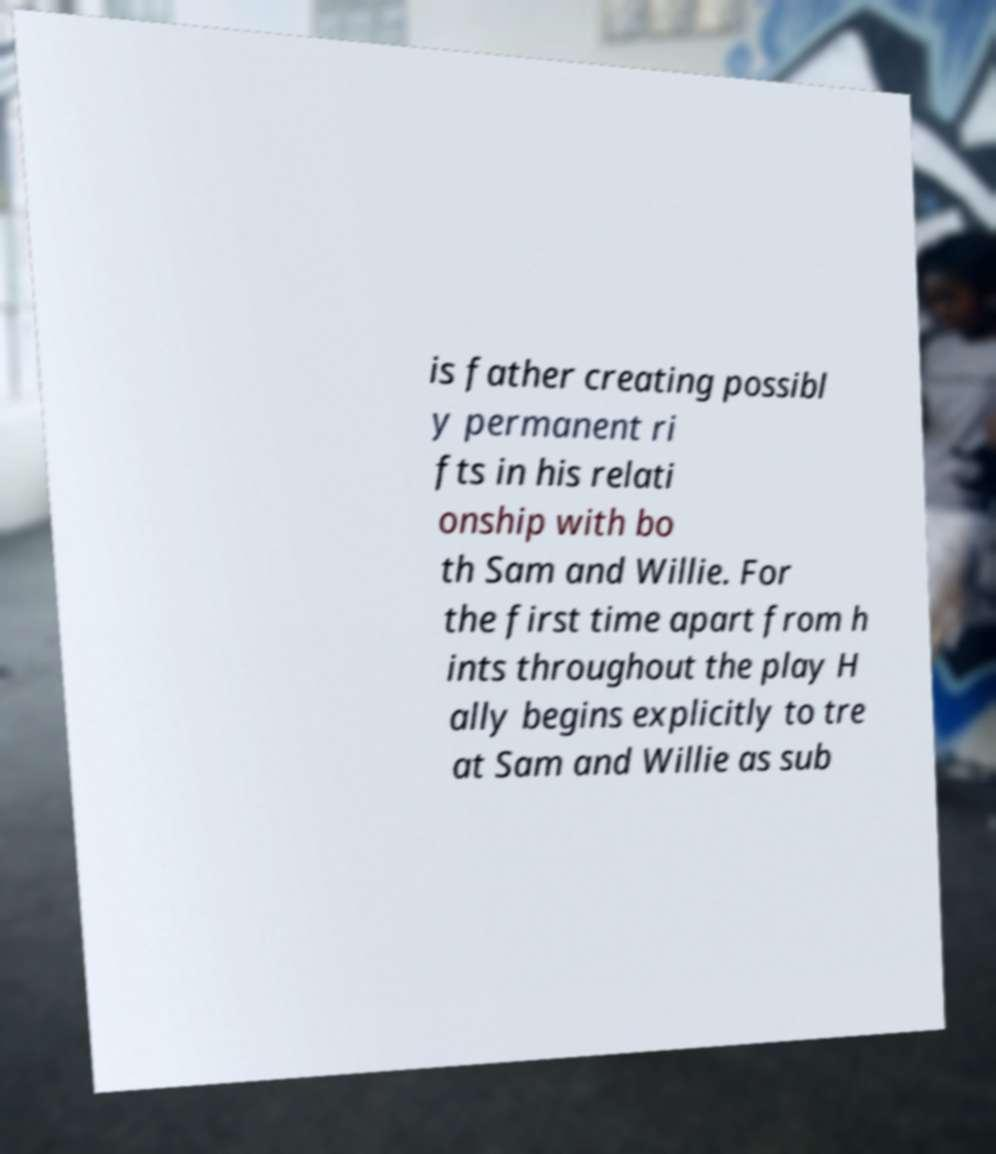Can you accurately transcribe the text from the provided image for me? is father creating possibl y permanent ri fts in his relati onship with bo th Sam and Willie. For the first time apart from h ints throughout the play H ally begins explicitly to tre at Sam and Willie as sub 